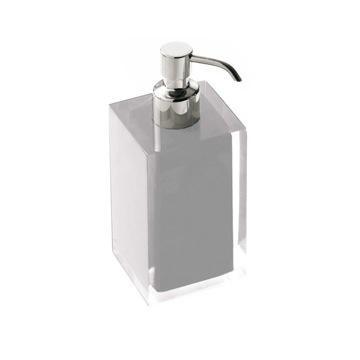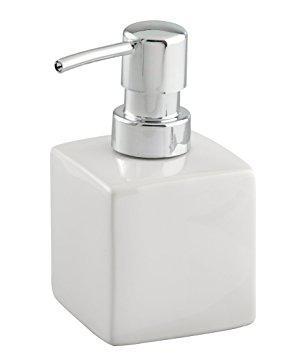The first image is the image on the left, the second image is the image on the right. For the images displayed, is the sentence "The dispenser on the right is taller than the dispenser on the left." factually correct? Answer yes or no. Yes. The first image is the image on the left, the second image is the image on the right. Evaluate the accuracy of this statement regarding the images: "soap dispensers are made of stone material". Is it true? Answer yes or no. No. 